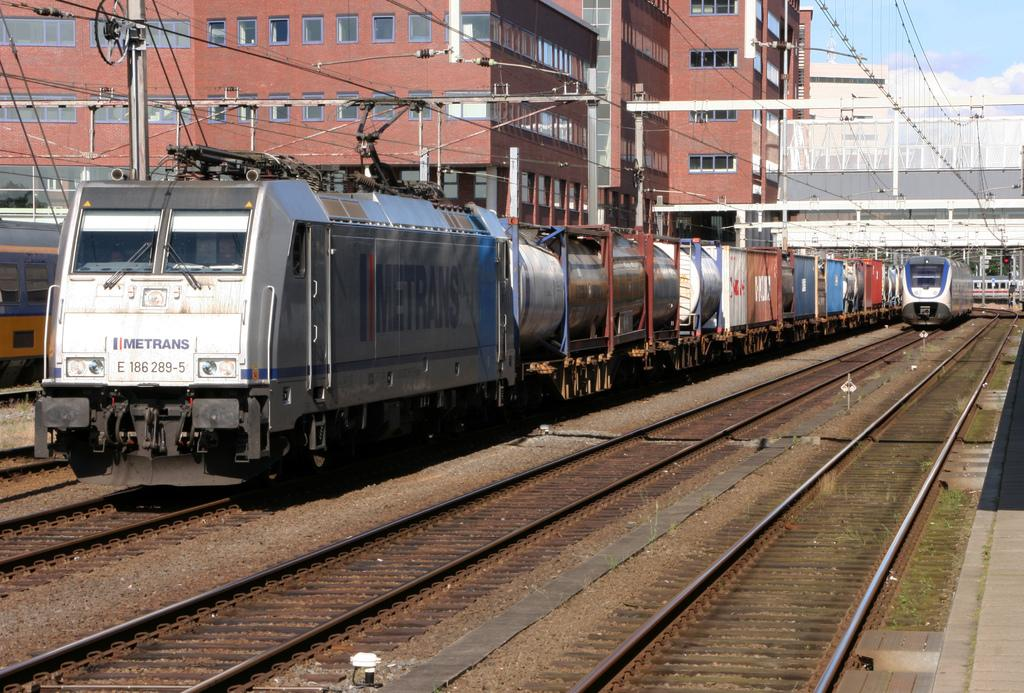<image>
Write a terse but informative summary of the picture. a train that has the word metrans on it 